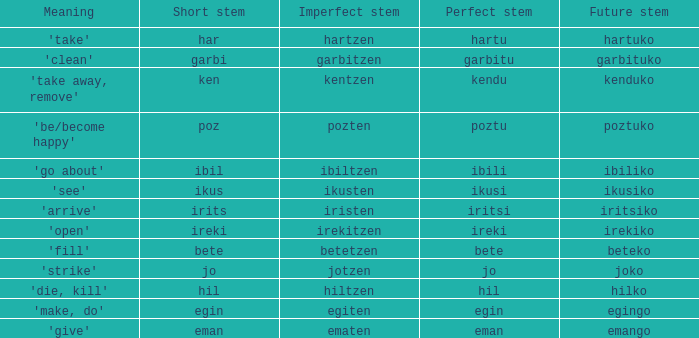I'm looking to parse the entire table for insights. Could you assist me with that? {'header': ['Meaning', 'Short stem', 'Imperfect stem', 'Perfect stem', 'Future stem'], 'rows': [["'take'", 'har', 'hartzen', 'hartu', 'hartuko'], ["'clean'", 'garbi', 'garbitzen', 'garbitu', 'garbituko'], ["'take away, remove'", 'ken', 'kentzen', 'kendu', 'kenduko'], ["'be/become happy'", 'poz', 'pozten', 'poztu', 'poztuko'], ["'go about'", 'ibil', 'ibiltzen', 'ibili', 'ibiliko'], ["'see'", 'ikus', 'ikusten', 'ikusi', 'ikusiko'], ["'arrive'", 'irits', 'iristen', 'iritsi', 'iritsiko'], ["'open'", 'ireki', 'irekitzen', 'ireki', 'irekiko'], ["'fill'", 'bete', 'betetzen', 'bete', 'beteko'], ["'strike'", 'jo', 'jotzen', 'jo', 'joko'], ["'die, kill'", 'hil', 'hiltzen', 'hil', 'hilko'], ["'make, do'", 'egin', 'egiten', 'egin', 'egingo'], ["'give'", 'eman', 'ematen', 'eman', 'emango']]} What is the short stem for garbitzen? Garbi. 